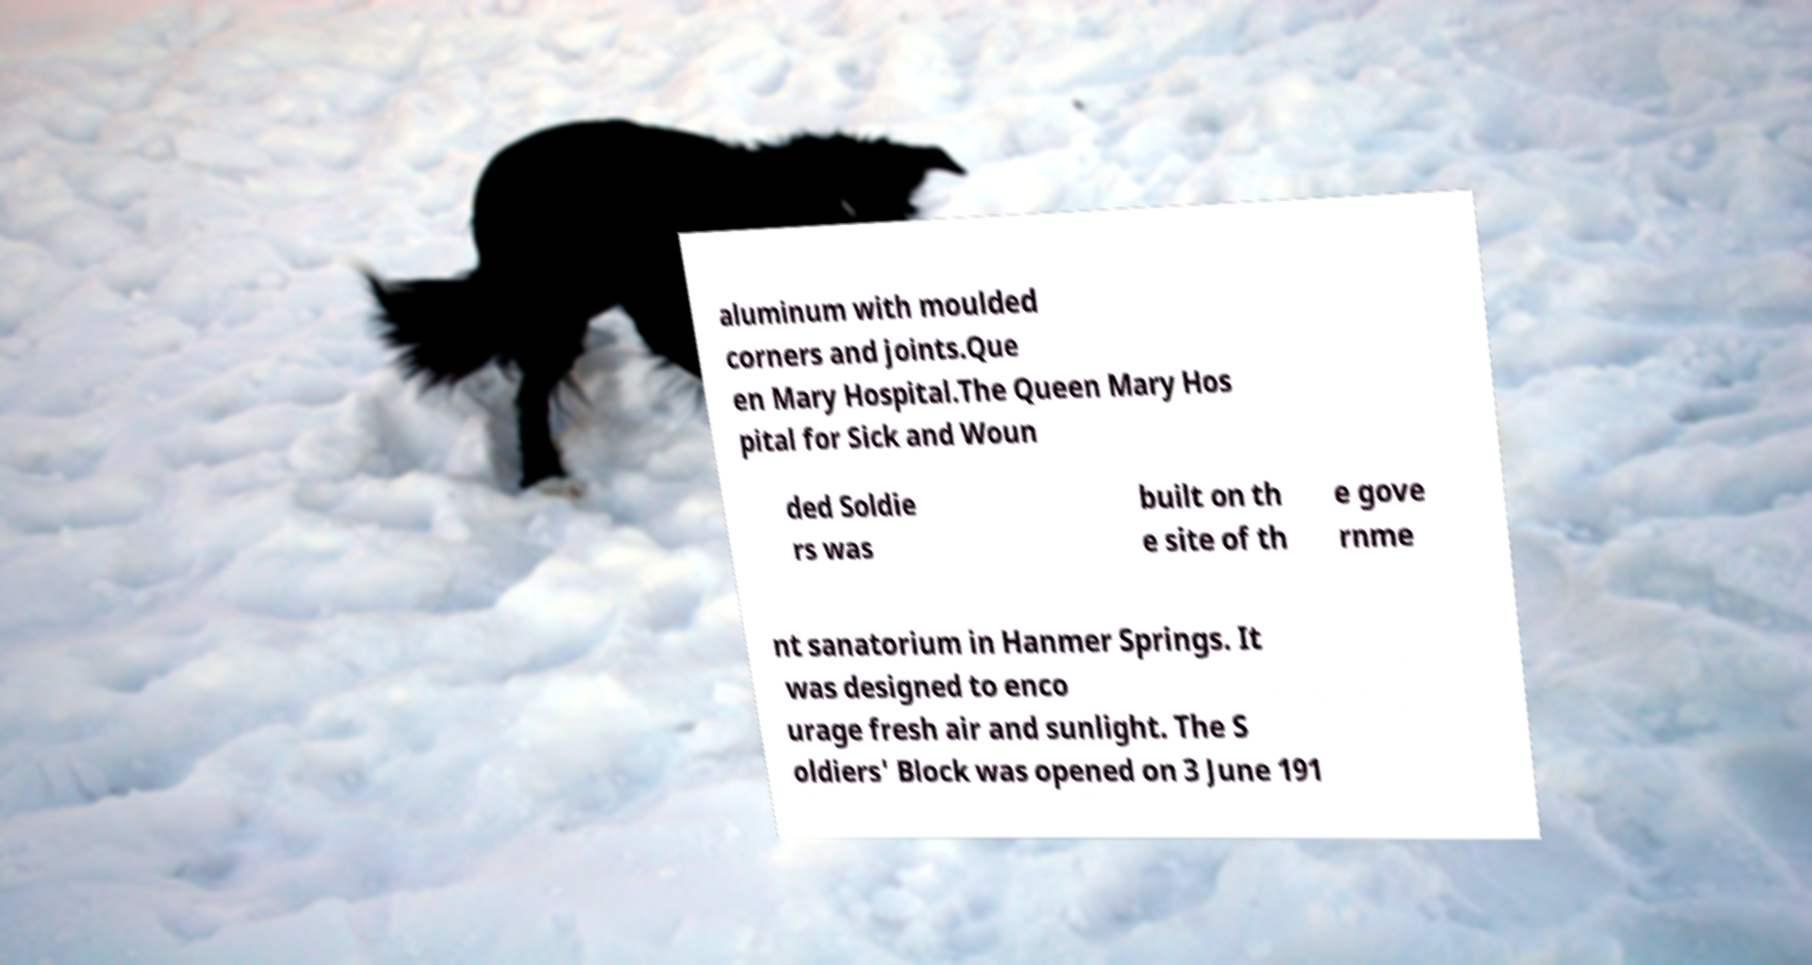There's text embedded in this image that I need extracted. Can you transcribe it verbatim? aluminum with moulded corners and joints.Que en Mary Hospital.The Queen Mary Hos pital for Sick and Woun ded Soldie rs was built on th e site of th e gove rnme nt sanatorium in Hanmer Springs. It was designed to enco urage fresh air and sunlight. The S oldiers' Block was opened on 3 June 191 